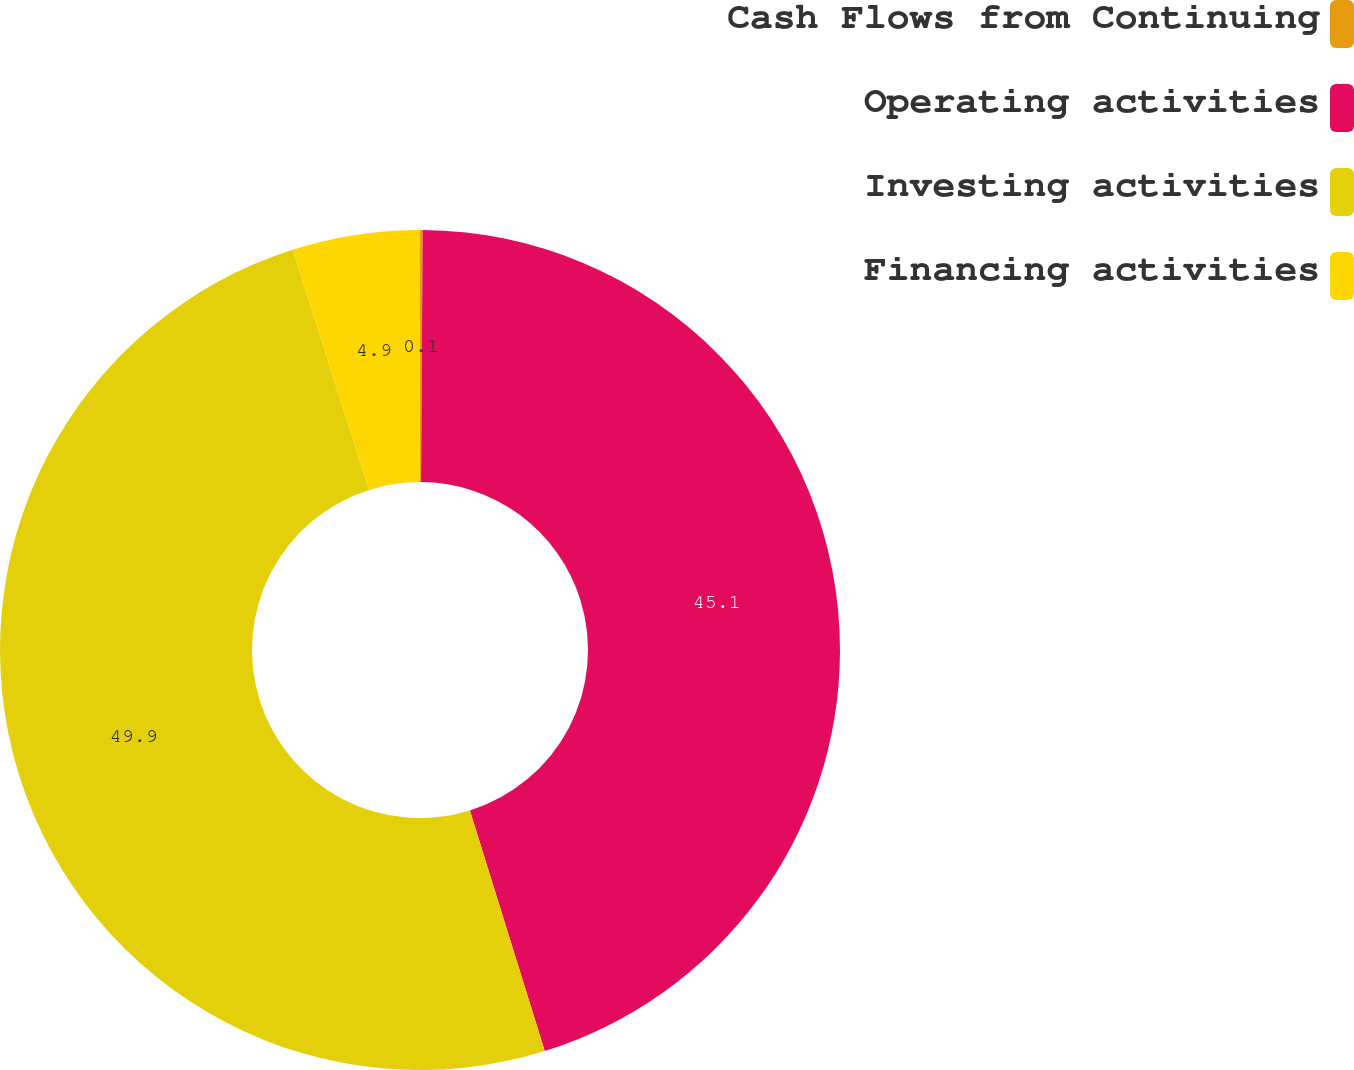Convert chart to OTSL. <chart><loc_0><loc_0><loc_500><loc_500><pie_chart><fcel>Cash Flows from Continuing<fcel>Operating activities<fcel>Investing activities<fcel>Financing activities<nl><fcel>0.1%<fcel>45.1%<fcel>49.9%<fcel>4.9%<nl></chart> 